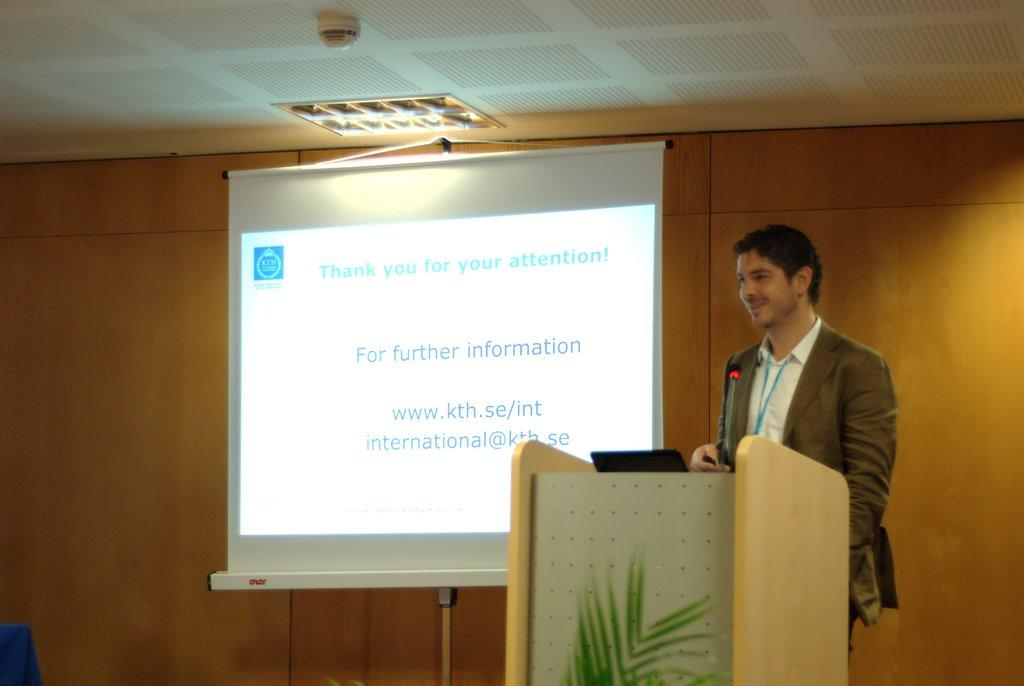<image>
Write a terse but informative summary of the picture. A man giving a presentation with the words for further information on a board 